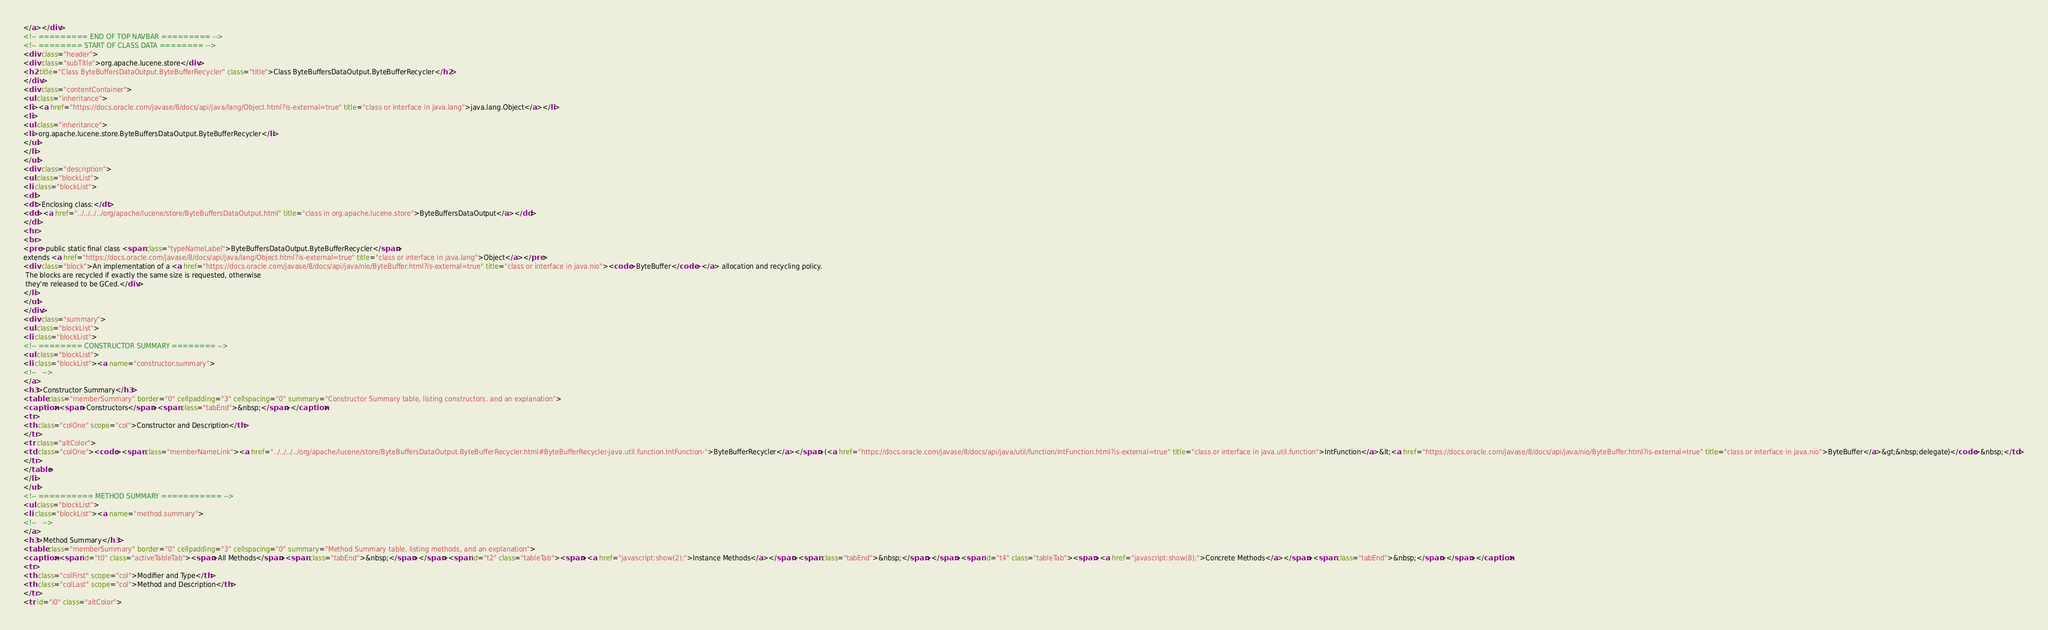Convert code to text. <code><loc_0><loc_0><loc_500><loc_500><_HTML_></a></div>
<!-- ========= END OF TOP NAVBAR ========= -->
<!-- ======== START OF CLASS DATA ======== -->
<div class="header">
<div class="subTitle">org.apache.lucene.store</div>
<h2 title="Class ByteBuffersDataOutput.ByteBufferRecycler" class="title">Class ByteBuffersDataOutput.ByteBufferRecycler</h2>
</div>
<div class="contentContainer">
<ul class="inheritance">
<li><a href="https://docs.oracle.com/javase/8/docs/api/java/lang/Object.html?is-external=true" title="class or interface in java.lang">java.lang.Object</a></li>
<li>
<ul class="inheritance">
<li>org.apache.lucene.store.ByteBuffersDataOutput.ByteBufferRecycler</li>
</ul>
</li>
</ul>
<div class="description">
<ul class="blockList">
<li class="blockList">
<dl>
<dt>Enclosing class:</dt>
<dd><a href="../../../../org/apache/lucene/store/ByteBuffersDataOutput.html" title="class in org.apache.lucene.store">ByteBuffersDataOutput</a></dd>
</dl>
<hr>
<br>
<pre>public static final class <span class="typeNameLabel">ByteBuffersDataOutput.ByteBufferRecycler</span>
extends <a href="https://docs.oracle.com/javase/8/docs/api/java/lang/Object.html?is-external=true" title="class or interface in java.lang">Object</a></pre>
<div class="block">An implementation of a <a href="https://docs.oracle.com/javase/8/docs/api/java/nio/ByteBuffer.html?is-external=true" title="class or interface in java.nio"><code>ByteBuffer</code></a> allocation and recycling policy.
 The blocks are recycled if exactly the same size is requested, otherwise
 they're released to be GCed.</div>
</li>
</ul>
</div>
<div class="summary">
<ul class="blockList">
<li class="blockList">
<!-- ======== CONSTRUCTOR SUMMARY ======== -->
<ul class="blockList">
<li class="blockList"><a name="constructor.summary">
<!--   -->
</a>
<h3>Constructor Summary</h3>
<table class="memberSummary" border="0" cellpadding="3" cellspacing="0" summary="Constructor Summary table, listing constructors, and an explanation">
<caption><span>Constructors</span><span class="tabEnd">&nbsp;</span></caption>
<tr>
<th class="colOne" scope="col">Constructor and Description</th>
</tr>
<tr class="altColor">
<td class="colOne"><code><span class="memberNameLink"><a href="../../../../org/apache/lucene/store/ByteBuffersDataOutput.ByteBufferRecycler.html#ByteBufferRecycler-java.util.function.IntFunction-">ByteBufferRecycler</a></span>(<a href="https://docs.oracle.com/javase/8/docs/api/java/util/function/IntFunction.html?is-external=true" title="class or interface in java.util.function">IntFunction</a>&lt;<a href="https://docs.oracle.com/javase/8/docs/api/java/nio/ByteBuffer.html?is-external=true" title="class or interface in java.nio">ByteBuffer</a>&gt;&nbsp;delegate)</code>&nbsp;</td>
</tr>
</table>
</li>
</ul>
<!-- ========== METHOD SUMMARY =========== -->
<ul class="blockList">
<li class="blockList"><a name="method.summary">
<!--   -->
</a>
<h3>Method Summary</h3>
<table class="memberSummary" border="0" cellpadding="3" cellspacing="0" summary="Method Summary table, listing methods, and an explanation">
<caption><span id="t0" class="activeTableTab"><span>All Methods</span><span class="tabEnd">&nbsp;</span></span><span id="t2" class="tableTab"><span><a href="javascript:show(2);">Instance Methods</a></span><span class="tabEnd">&nbsp;</span></span><span id="t4" class="tableTab"><span><a href="javascript:show(8);">Concrete Methods</a></span><span class="tabEnd">&nbsp;</span></span></caption>
<tr>
<th class="colFirst" scope="col">Modifier and Type</th>
<th class="colLast" scope="col">Method and Description</th>
</tr>
<tr id="i0" class="altColor"></code> 